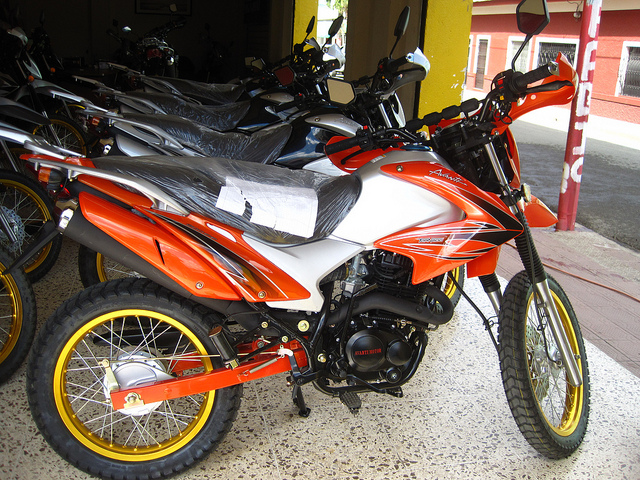Describe the color and design features of the motorcycles in the image. The primary motorcycle in the image boasts a striking combination of orange and white with fine details and accents, such as the bright yellow rims that add a touch of flair. The motorcycle's design suggests robustness and agility. The motorcycles in the background appear mostly in neutral colors like black, suggesting a variety of models on display. How might the colors of the motorcycles influence a customer's buying decision? The vibrant orange color of the primary motorcycle is likely to attract customers looking for a stylish and noticeable ride. Bright colors often signal excitement and can appeal to those wanting to make a statement. On the other hand, the more neutral colors of the motorcycles in the background might appeal to customers seeking a versatile and understated look, ideal for everyday use. 